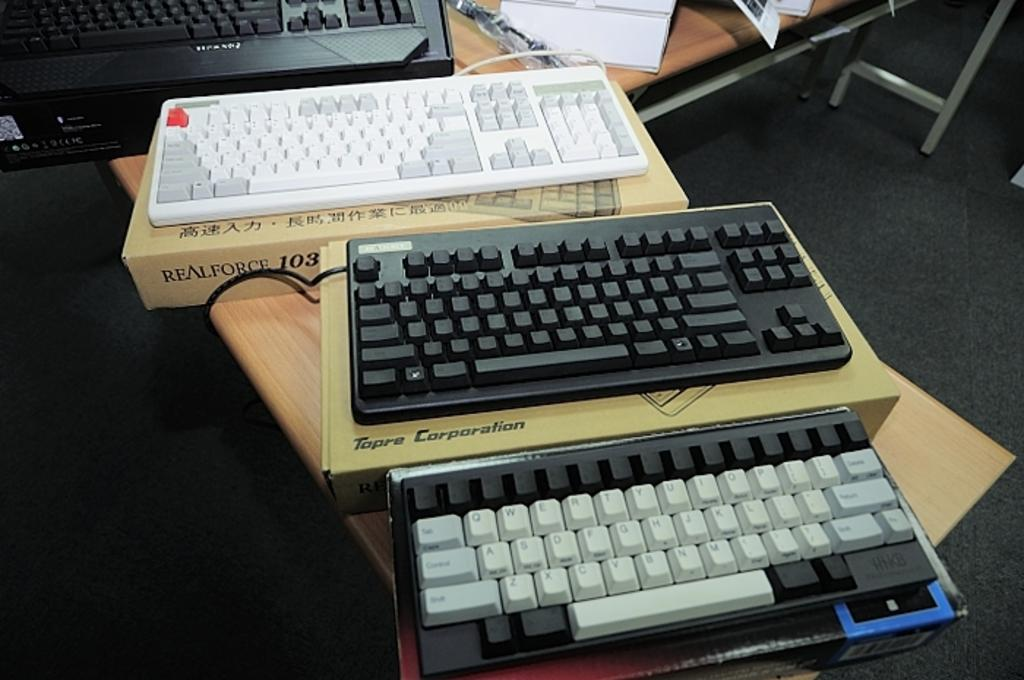<image>
Describe the image concisely. A realforce keyboard sits on a wooden desk above a Tapre corp keyboard. 